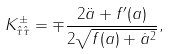<formula> <loc_0><loc_0><loc_500><loc_500>K _ { \hat { \tau } \hat { \tau } } ^ { \pm } = \mp \frac { 2 \ddot { a } + f ^ { \prime } ( a ) } { 2 \sqrt { f ( a ) + \dot { a } ^ { 2 } } } ,</formula> 